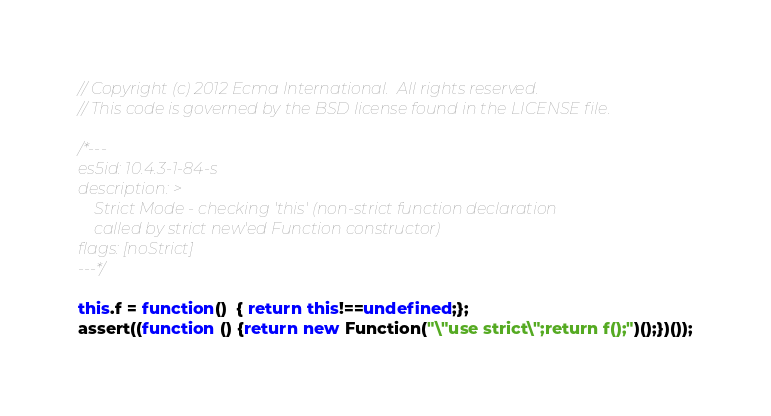Convert code to text. <code><loc_0><loc_0><loc_500><loc_500><_JavaScript_>// Copyright (c) 2012 Ecma International.  All rights reserved.
// This code is governed by the BSD license found in the LICENSE file.

/*---
es5id: 10.4.3-1-84-s
description: >
    Strict Mode - checking 'this' (non-strict function declaration
    called by strict new'ed Function constructor)
flags: [noStrict]
---*/

this.f = function()  { return this!==undefined;};
assert((function () {return new Function("\"use strict\";return f();")();})());
</code> 